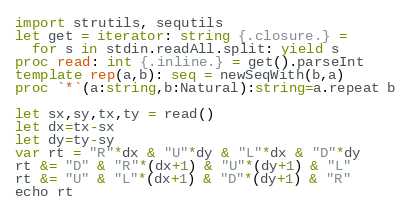<code> <loc_0><loc_0><loc_500><loc_500><_Nim_>import strutils, sequtils
let get = iterator: string {.closure.} =
  for s in stdin.readAll.split: yield s
proc read: int {.inline.} = get().parseInt
template rep(a,b): seq = newSeqWith(b,a)
proc `*`(a:string,b:Natural):string=a.repeat b

let sx,sy,tx,ty = read()
let dx=tx-sx
let dy=ty-sy
var rt = "R"*dx & "U"*dy & "L"*dx & "D"*dy
rt &= "D" & "R"*(dx+1) & "U"*(dy+1) & "L"
rt &= "U" & "L"*(dx+1) & "D"*(dy+1) & "R"
echo rt</code> 